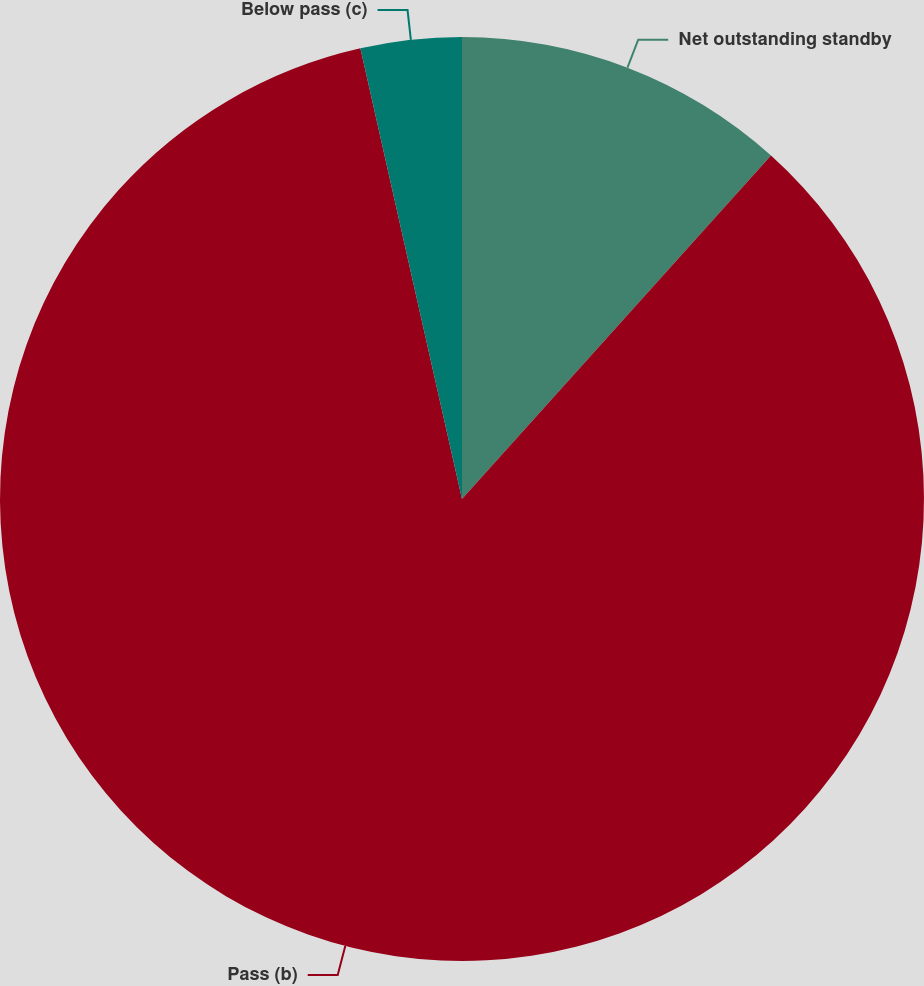Convert chart. <chart><loc_0><loc_0><loc_500><loc_500><pie_chart><fcel>Net outstanding standby<fcel>Pass (b)<fcel>Below pass (c)<nl><fcel>11.66%<fcel>84.81%<fcel>3.53%<nl></chart> 